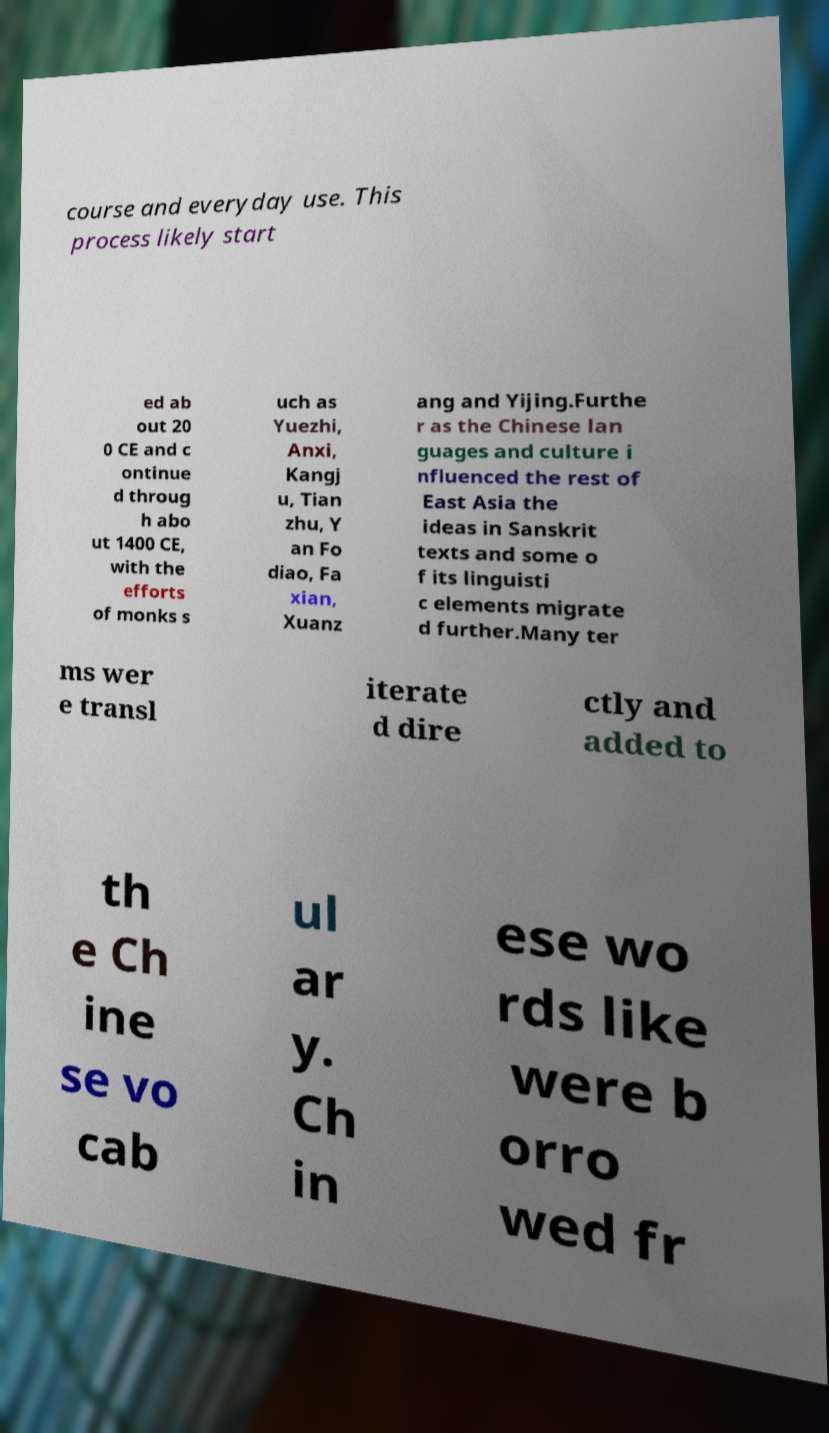Can you read and provide the text displayed in the image?This photo seems to have some interesting text. Can you extract and type it out for me? course and everyday use. This process likely start ed ab out 20 0 CE and c ontinue d throug h abo ut 1400 CE, with the efforts of monks s uch as Yuezhi, Anxi, Kangj u, Tian zhu, Y an Fo diao, Fa xian, Xuanz ang and Yijing.Furthe r as the Chinese lan guages and culture i nfluenced the rest of East Asia the ideas in Sanskrit texts and some o f its linguisti c elements migrate d further.Many ter ms wer e transl iterate d dire ctly and added to th e Ch ine se vo cab ul ar y. Ch in ese wo rds like were b orro wed fr 